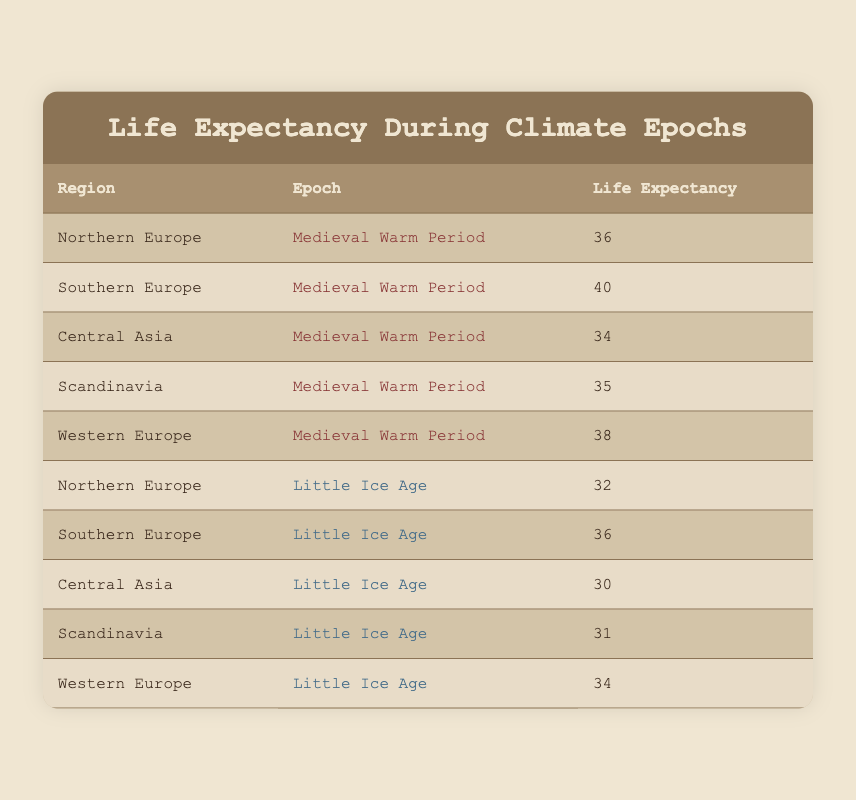What is the life expectancy in Central Asia during the Medieval Warm Period? According to the table, the life expectancy in Central Asia during the Medieval Warm Period is listed as 34.
Answer: 34 Which region experienced the highest life expectancy during the Medieval Warm Period? The table shows that Southern Europe had the highest life expectancy during the Medieval Warm Period at 40.
Answer: 40 What is the difference in life expectancy for Northern Europe between the Medieval Warm Period and the Little Ice Age? For Northern Europe, the life expectancy during the Medieval Warm Period is 36 and during the Little Ice Age is 32. The difference is calculated as 36 - 32 = 4.
Answer: 4 Was the life expectancy in Western Europe higher during the Little Ice Age compared to Northern Europe? In the table, Western Europe had a life expectancy of 34 during the Little Ice Age, while Northern Europe had a life expectancy of 32. Since 34 is greater than 32, the answer is yes.
Answer: Yes What is the average life expectancy across all regions during the Little Ice Age? The life expectancies during the Little Ice Age are: Northern Europe (32), Southern Europe (36), Central Asia (30), Scandinavia (31), and Western Europe (34). To compute the average, we sum these values: 32 + 36 + 30 + 31 + 34 = 163. There are 5 data points, so the average is 163 / 5 = 32.6.
Answer: 32.6 